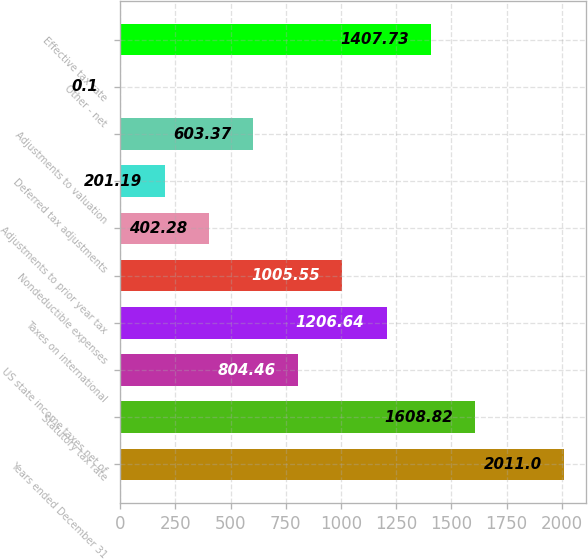Convert chart to OTSL. <chart><loc_0><loc_0><loc_500><loc_500><bar_chart><fcel>Years ended December 31<fcel>Statutory tax rate<fcel>US state income taxes net of<fcel>Taxes on international<fcel>Nondeductible expenses<fcel>Adjustments to prior year tax<fcel>Deferred tax adjustments<fcel>Adjustments to valuation<fcel>Other - net<fcel>Effective tax rate<nl><fcel>2011<fcel>1608.82<fcel>804.46<fcel>1206.64<fcel>1005.55<fcel>402.28<fcel>201.19<fcel>603.37<fcel>0.1<fcel>1407.73<nl></chart> 